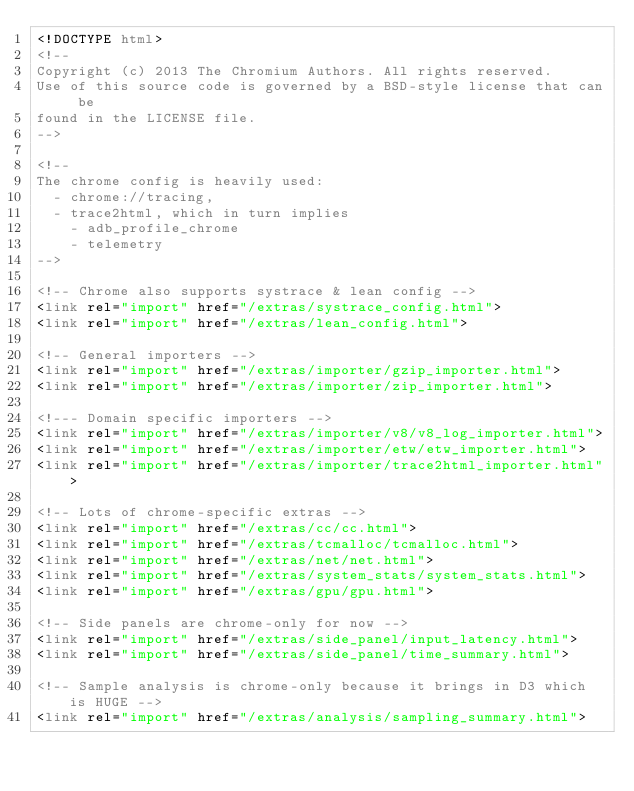Convert code to text. <code><loc_0><loc_0><loc_500><loc_500><_HTML_><!DOCTYPE html>
<!--
Copyright (c) 2013 The Chromium Authors. All rights reserved.
Use of this source code is governed by a BSD-style license that can be
found in the LICENSE file.
-->

<!--
The chrome config is heavily used:
  - chrome://tracing,
  - trace2html, which in turn implies
    - adb_profile_chrome
    - telemetry
-->

<!-- Chrome also supports systrace & lean config -->
<link rel="import" href="/extras/systrace_config.html">
<link rel="import" href="/extras/lean_config.html">

<!-- General importers -->
<link rel="import" href="/extras/importer/gzip_importer.html">
<link rel="import" href="/extras/importer/zip_importer.html">

<!--- Domain specific importers -->
<link rel="import" href="/extras/importer/v8/v8_log_importer.html">
<link rel="import" href="/extras/importer/etw/etw_importer.html">
<link rel="import" href="/extras/importer/trace2html_importer.html">

<!-- Lots of chrome-specific extras -->
<link rel="import" href="/extras/cc/cc.html">
<link rel="import" href="/extras/tcmalloc/tcmalloc.html">
<link rel="import" href="/extras/net/net.html">
<link rel="import" href="/extras/system_stats/system_stats.html">
<link rel="import" href="/extras/gpu/gpu.html">

<!-- Side panels are chrome-only for now -->
<link rel="import" href="/extras/side_panel/input_latency.html">
<link rel="import" href="/extras/side_panel/time_summary.html">

<!-- Sample analysis is chrome-only because it brings in D3 which is HUGE -->
<link rel="import" href="/extras/analysis/sampling_summary.html">
</code> 